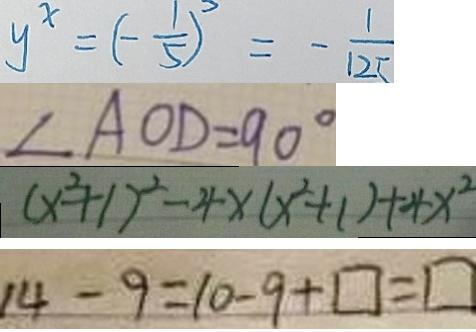<formula> <loc_0><loc_0><loc_500><loc_500>y ^ { x } = ( - \frac { 1 } { 5 } ) ^ { 3 } = - \frac { 1 } { 1 2 5 } 
 \angle A O D = 9 0 ^ { \circ } 
 ( x ^ { 2 } + 1 ) ^ { 2 } - 4 x ( x ^ { 2 } + 1 ) + 4 x ^ { 2 } 
 1 4 - 9 = 1 0 - 9 + \square = \square</formula> 